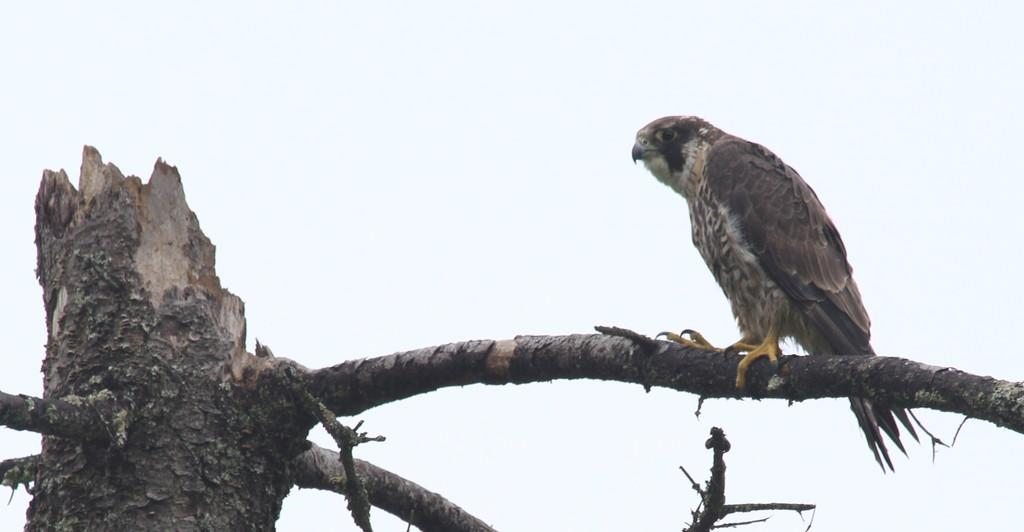What animal can be seen in the image? There is an eagle in the image. Where is the eagle located? The eagle is standing on a branch of a tree. What can be seen in the background of the image? The sky is visible in the background of the image. What is the price of the ear in the image? There is no ear present in the image, and therefore no price can be determined. 